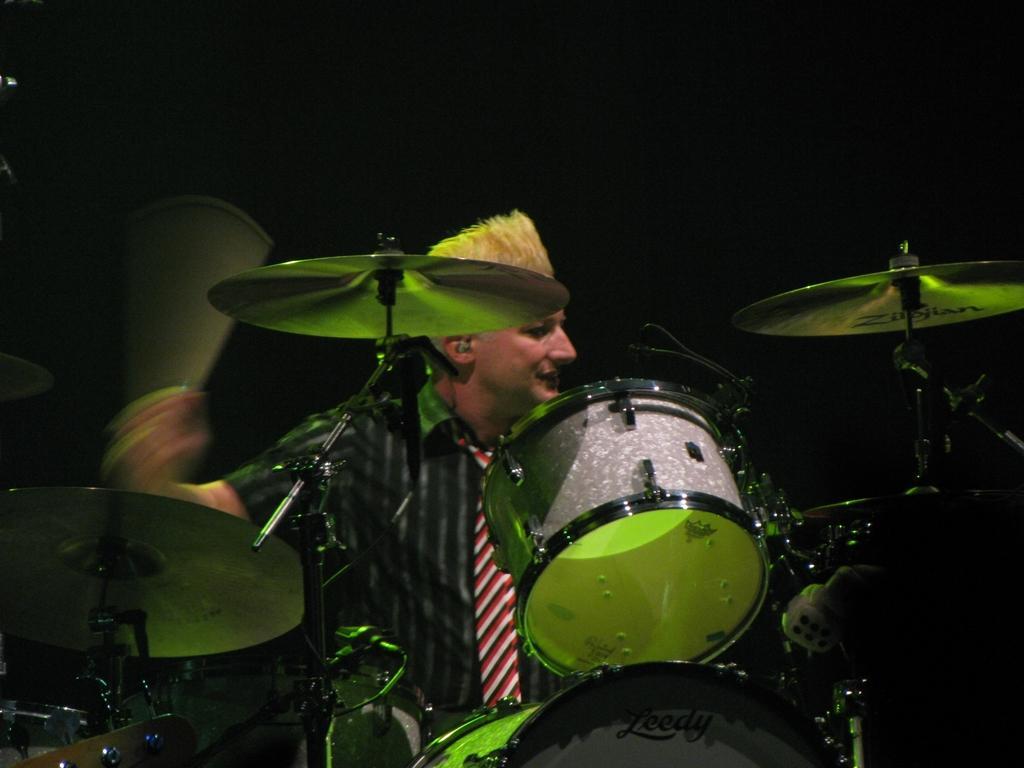Describe this image in one or two sentences. In there is a man playing a drum. 